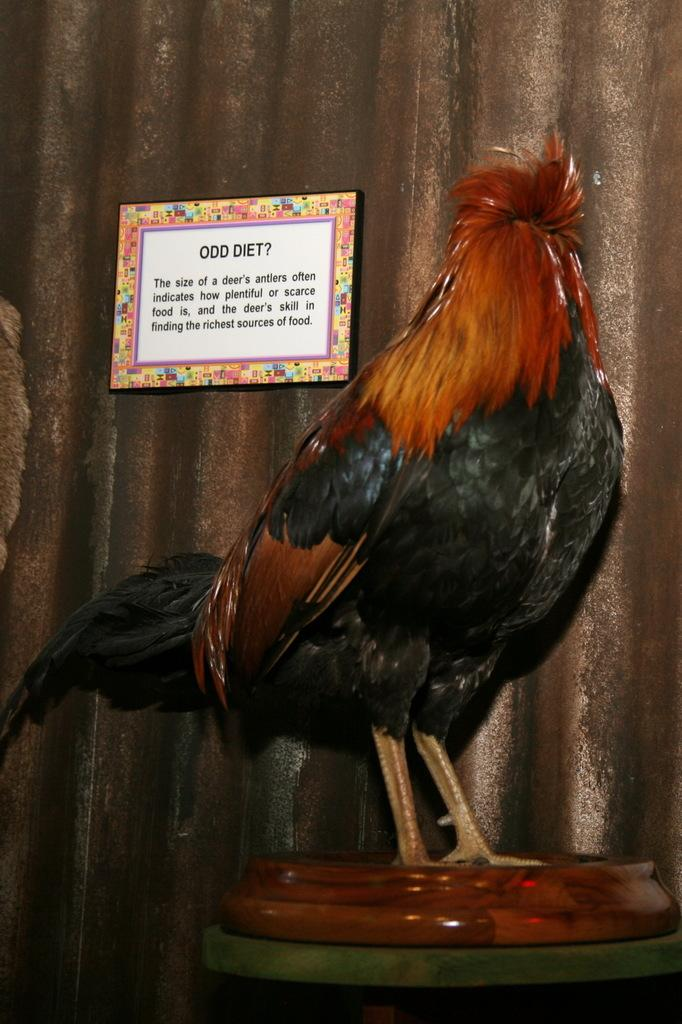What animal is in the image? There is a cock in the image. Where is the cock located? The cock is on a platform. What can be seen on the wall in the background of the image? There is a frame on the wall in the background of the image. How many lizards are crawling on the frame in the image? There are no lizards present in the image; it only features a cock on a platform and a frame on the wall. What type of jewel is hanging from the cock's neck in the image? There is no jewel hanging from the cock's neck in the image; it is simply a cock on a platform. 